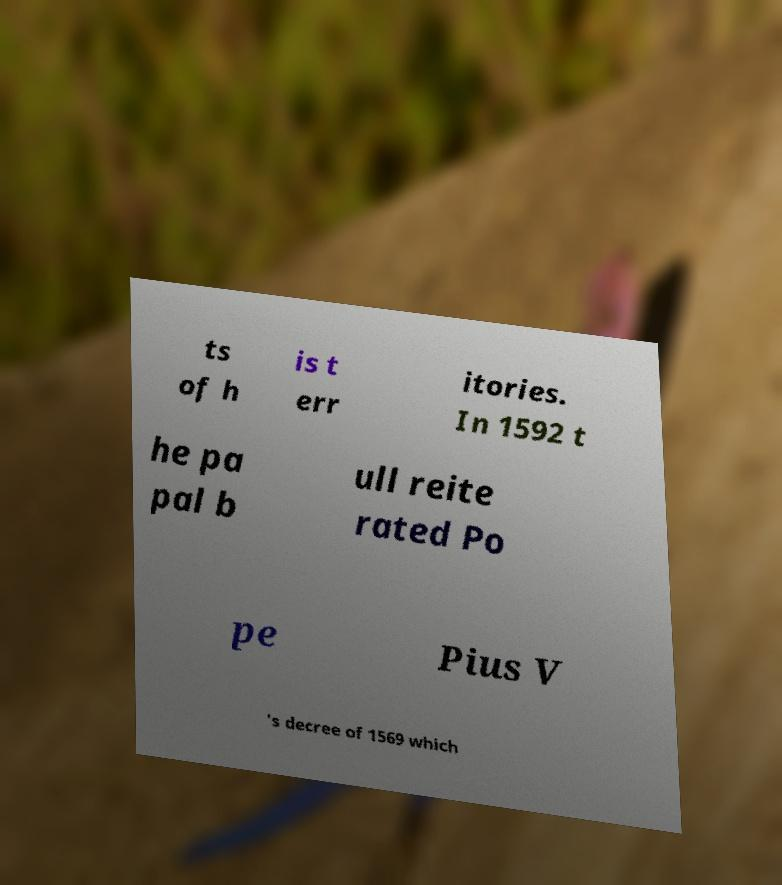Please identify and transcribe the text found in this image. ts of h is t err itories. In 1592 t he pa pal b ull reite rated Po pe Pius V 's decree of 1569 which 